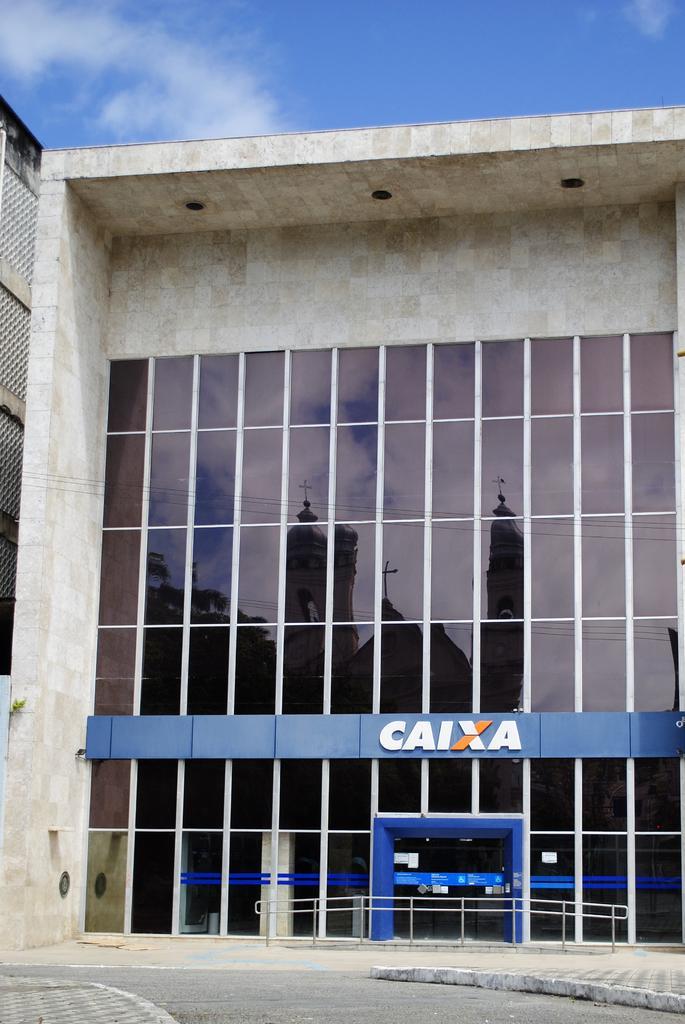In one or two sentences, can you explain what this image depicts? In this image we can see a building, railing, name board and sky with clouds. 